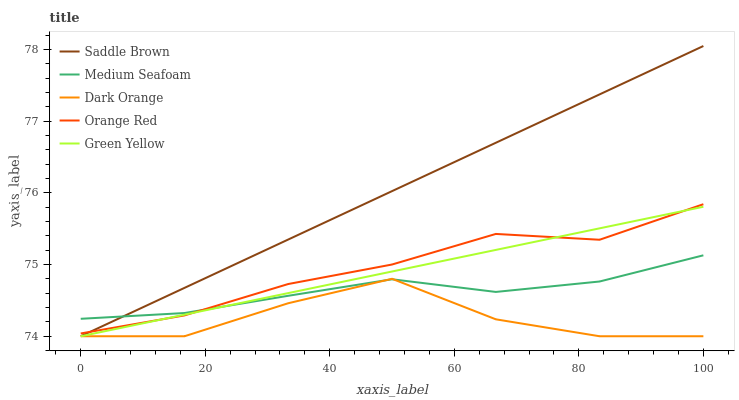Does Green Yellow have the minimum area under the curve?
Answer yes or no. No. Does Green Yellow have the maximum area under the curve?
Answer yes or no. No. Is Green Yellow the smoothest?
Answer yes or no. No. Is Green Yellow the roughest?
Answer yes or no. No. Does Orange Red have the lowest value?
Answer yes or no. No. Does Green Yellow have the highest value?
Answer yes or no. No. Is Dark Orange less than Orange Red?
Answer yes or no. Yes. Is Orange Red greater than Dark Orange?
Answer yes or no. Yes. Does Dark Orange intersect Orange Red?
Answer yes or no. No. 